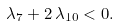<formula> <loc_0><loc_0><loc_500><loc_500>\lambda _ { 7 } + 2 \, \lambda _ { 1 0 } < 0 .</formula> 